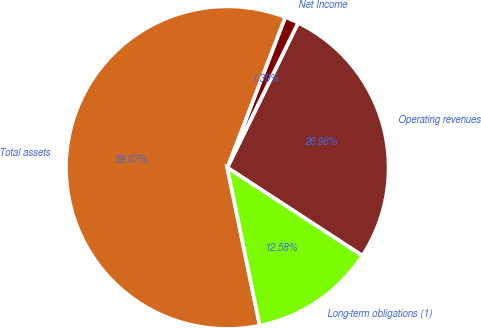<chart> <loc_0><loc_0><loc_500><loc_500><pie_chart><fcel>Operating revenues<fcel>Net Income<fcel>Total assets<fcel>Long-term obligations (1)<nl><fcel>26.96%<fcel>1.39%<fcel>59.07%<fcel>12.58%<nl></chart> 